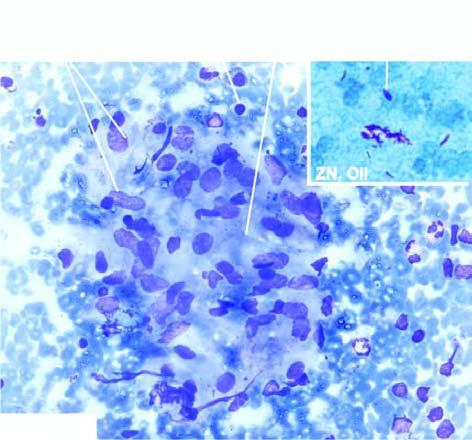what shows ziehl-neelsen staining having many tubercle bacilli?
Answer the question using a single word or phrase. Fna lymph node 